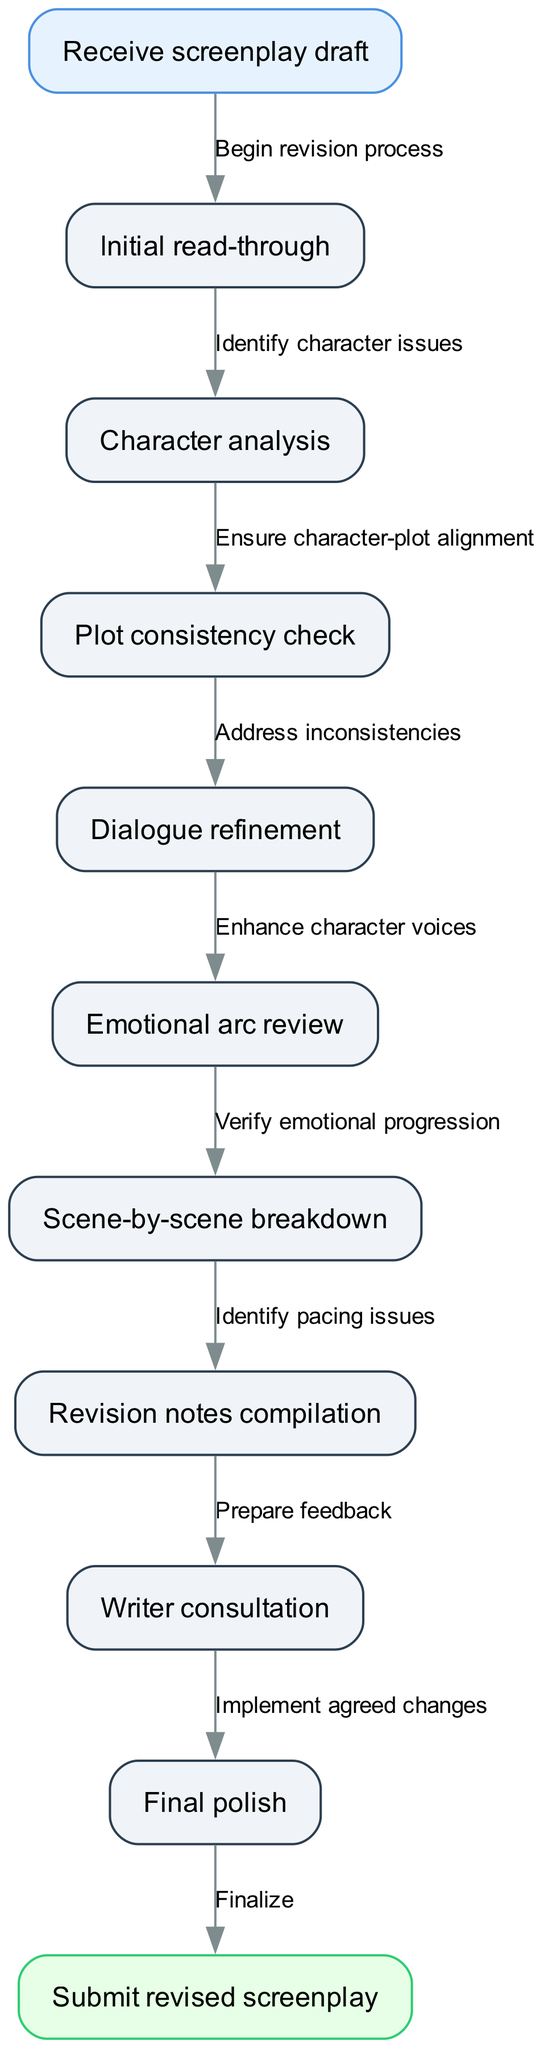What is the first step in the screenplay revision process? The diagram indicates that the first step is to "Receive screenplay draft," as shown in the starting node.
Answer: Receive screenplay draft How many nodes are present in the diagram? By counting the individual nodes listed in the data, there are a total of nine process nodes, plus one start and one end node, giving a total of 11 nodes.
Answer: 11 What is the last action before submitting the revised screenplay? From the diagram, the action just before submitting the revised screenplay is "Finalize," which is shown as the connection from the last process node to the end node.
Answer: Finalize Which step comes after "Character analysis"? The flow from "Character analysis" leads directly to "Plot consistency check," as indicated by the edges in the diagram.
Answer: Plot consistency check What is the relationship between "Dialogue refinement" and "Emotional arc review"? The diagram shows that "Dialogue refinement" precedes "Emotional arc review," meaning that the dialogue must be refined before reviewing the emotional arc of the screenplay.
Answer: Dialogue refinement precedes Emotional arc review How many edges connect the nodes in the diagram? Each connection between nodes is an edge, and by counting these edges in the diagram, there are eight defined edges that connect the nodes together, leading to the end.
Answer: 8 What must be done after the "Scene-by-scene breakdown"? According to the diagram, after the "Scene-by-scene breakdown," the next step is to "Identify pacing issues," indicating that this is a critical checkpoint in the workflow.
Answer: Identify pacing issues What is the purpose of "Writer consultation"? The diagram indicates that the purpose of "Writer consultation" is to "Prepare feedback," which implies discussing the revisions made and gathering additional insights or suggestions.
Answer: Prepare feedback Which process ensures character issues are addressed? The step that specifically addresses identifying character issues is "Character analysis," as shown in the flow after the initial read-through.
Answer: Character analysis 